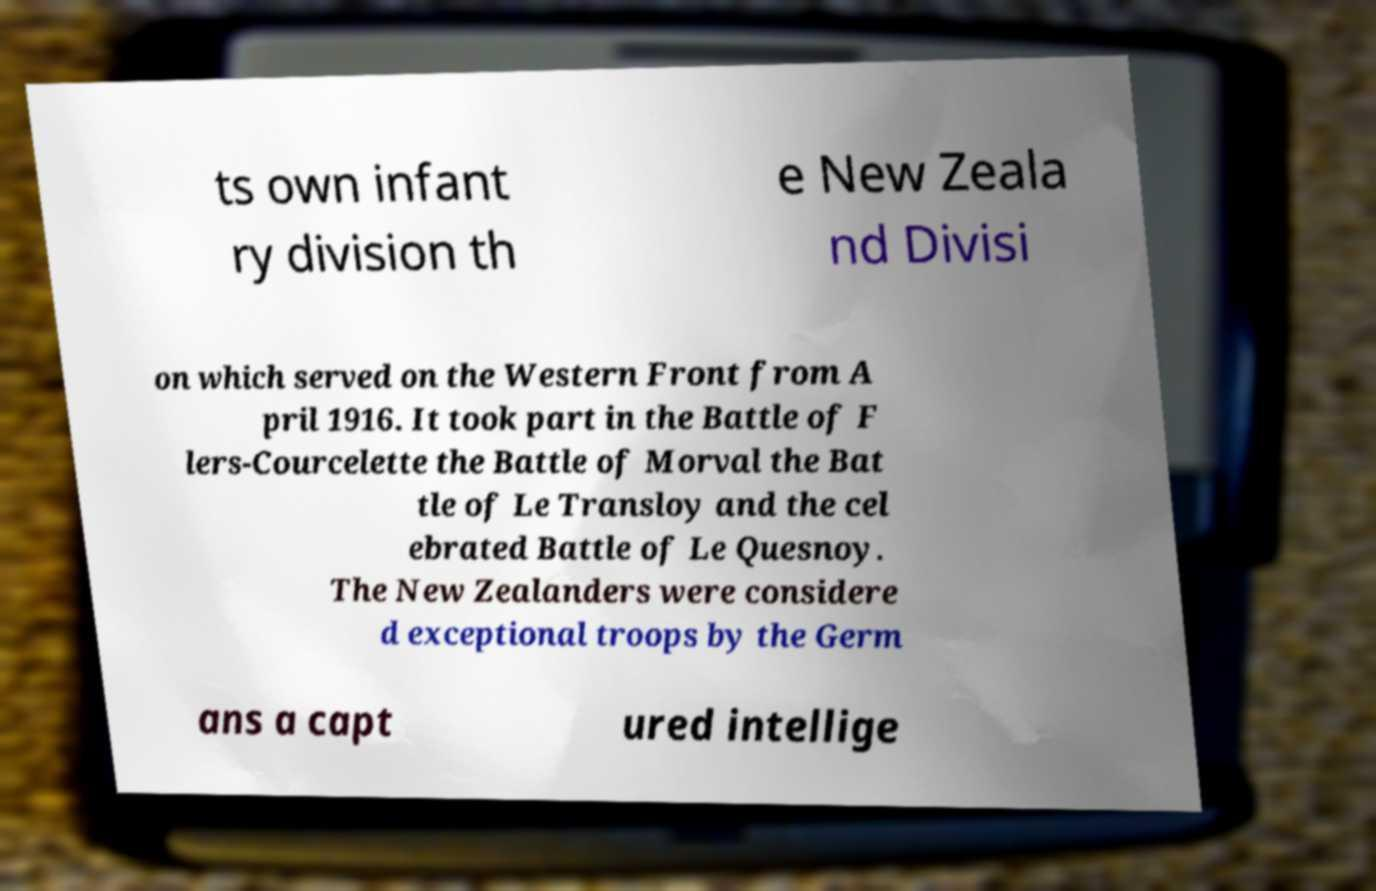For documentation purposes, I need the text within this image transcribed. Could you provide that? ts own infant ry division th e New Zeala nd Divisi on which served on the Western Front from A pril 1916. It took part in the Battle of F lers-Courcelette the Battle of Morval the Bat tle of Le Transloy and the cel ebrated Battle of Le Quesnoy. The New Zealanders were considere d exceptional troops by the Germ ans a capt ured intellige 